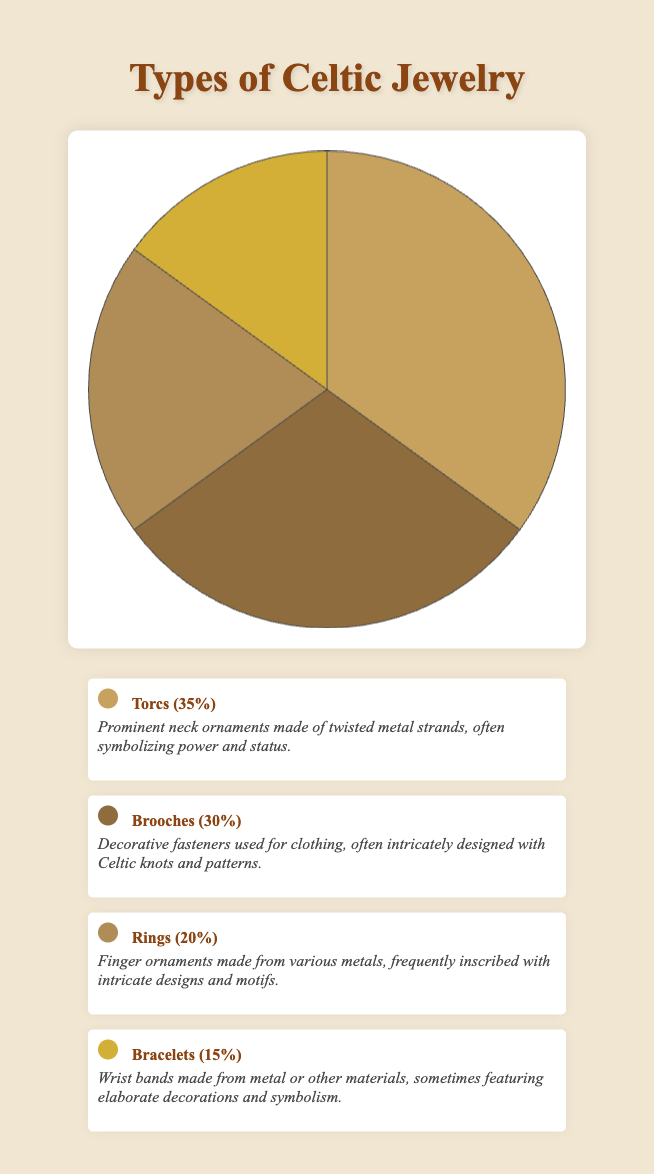Which type of Celtic jewelry has the highest percentage? The figure shows the distribution of different types of Celtic jewelry. By observing the slices, Torcs occupy the largest segment at 35%.
Answer: Torcs Which jewelry type is represented in the smallest segment of the pie chart? By looking at the pie chart, Bracelets are the smallest segment, taking up only 15% of the chart.
Answer: Bracelets What is the combined percentage of Brooches and Rings? Referencing the pie chart, Brooches account for 30% and Rings make up 20%. Adding both together, 30% + 20% = 50%.
Answer: 50% How much more common are Torcs than Bracelets? To determine the difference between their percentages, look at Torcs (35%) and Bracelets (15%). Subtracting these values: 35% - 15% = 20%.
Answer: 20% Which category is only slightly less common than Torcs? Torcs hold 35% of the chart. The next largest segment is for Brooches at 30%, which is slightly less common.
Answer: Brooches If we combined the percentages of Rings and Bracelets, how does their total compare to Torcs? Rings have 20% and Bracelets have 15%. Adding these gives 35%, which is equal to the percentage of Torcs.
Answer: Equal What is the average percentage of Rings and Bracelets? Combine the percentages of Rings (20%) and Bracelets (15%) and divide by 2: (20% + 15%) / 2 = 17.5%.
Answer: 17.5% If the percentage of Torcs doubled, what would it be? The current percentage of Torcs is 35%. Doubling it, 35% * 2 = 70%.
Answer: 70% Which jewelry type uses intricate designs primarily meant for clothing? Referring to the descriptions, Brooches are noted for their intricate designs used as decorative fasteners for clothing.
Answer: Brooches What percentage of the Celtic jewelry does not include Rings? The total percentage for Rings is 20%. Subtract this from 100% to get the portion without Rings: 100% - 20% = 80%.
Answer: 80% 